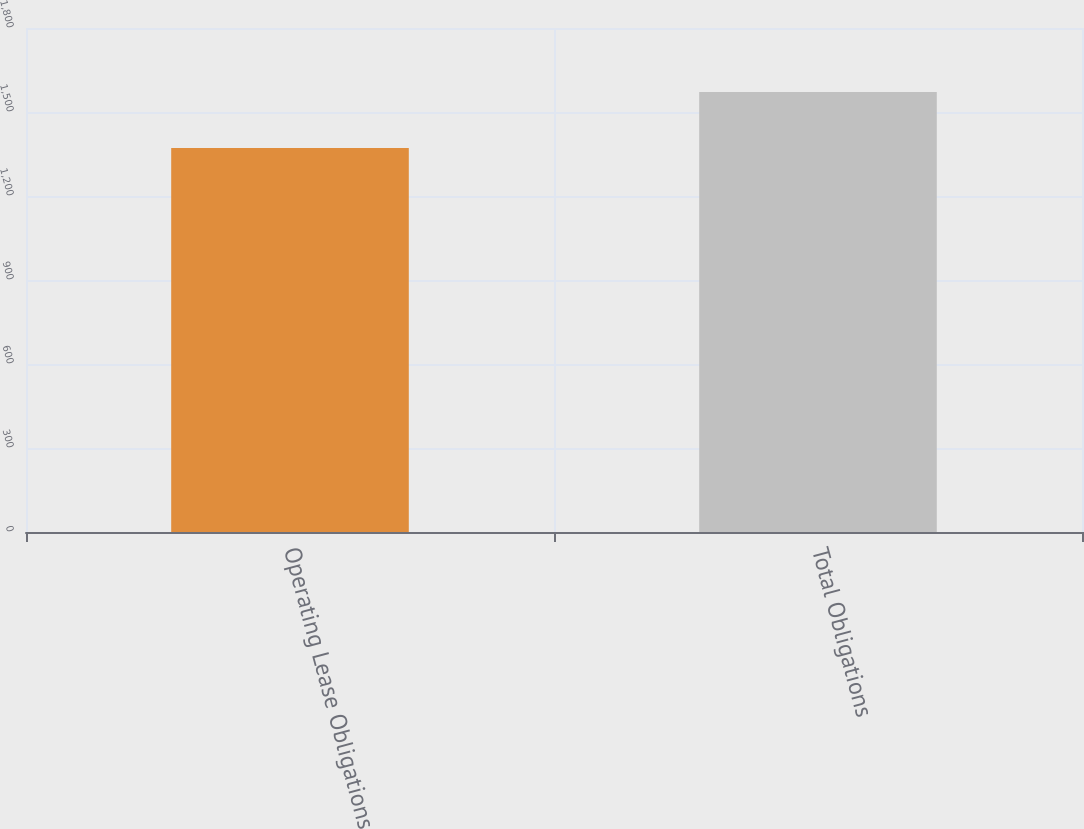Convert chart to OTSL. <chart><loc_0><loc_0><loc_500><loc_500><bar_chart><fcel>Operating Lease Obligations<fcel>Total Obligations<nl><fcel>1371<fcel>1571<nl></chart> 